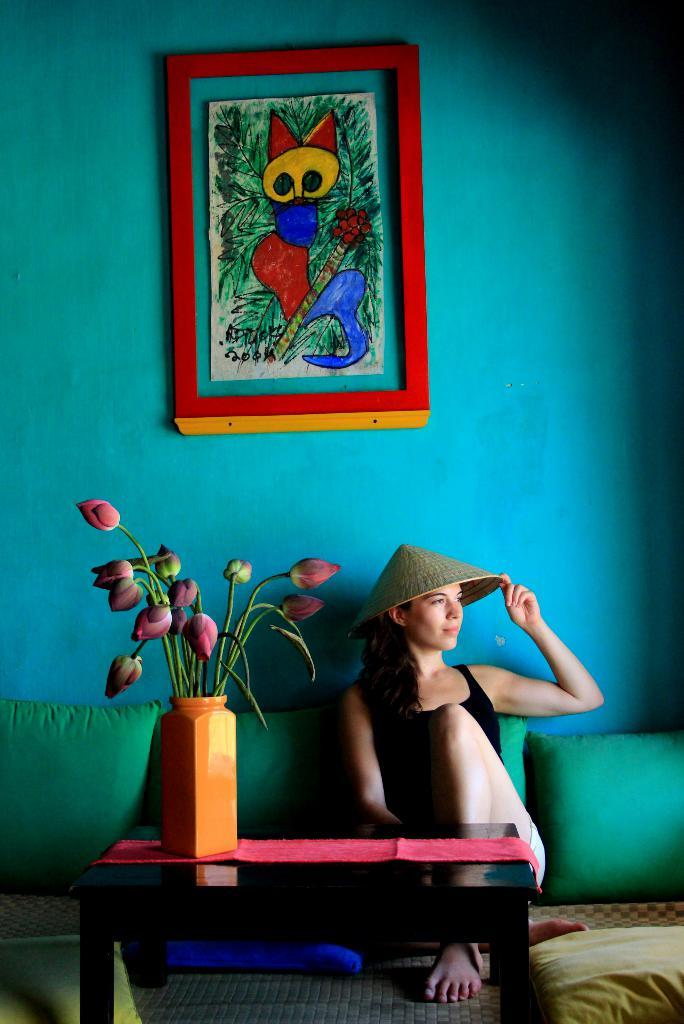What is hanging on the wall in the image? There is a painting frame on a wall in the image. What is the woman in the image doing? The woman is sitting on a sofa in the image. What is the woman wearing on her head? The woman is wearing a hat in the image. What piece of furniture is present in the image besides the sofa? There is a table in the image. What can be found on the table in the image? There is a flower vase on the table in the image. What direction is the hour blowing in the image? There is no hour or blowing action present in the image. What type of direction is the woman facing in the image? The image does not provide information about the direction the woman is facing. 